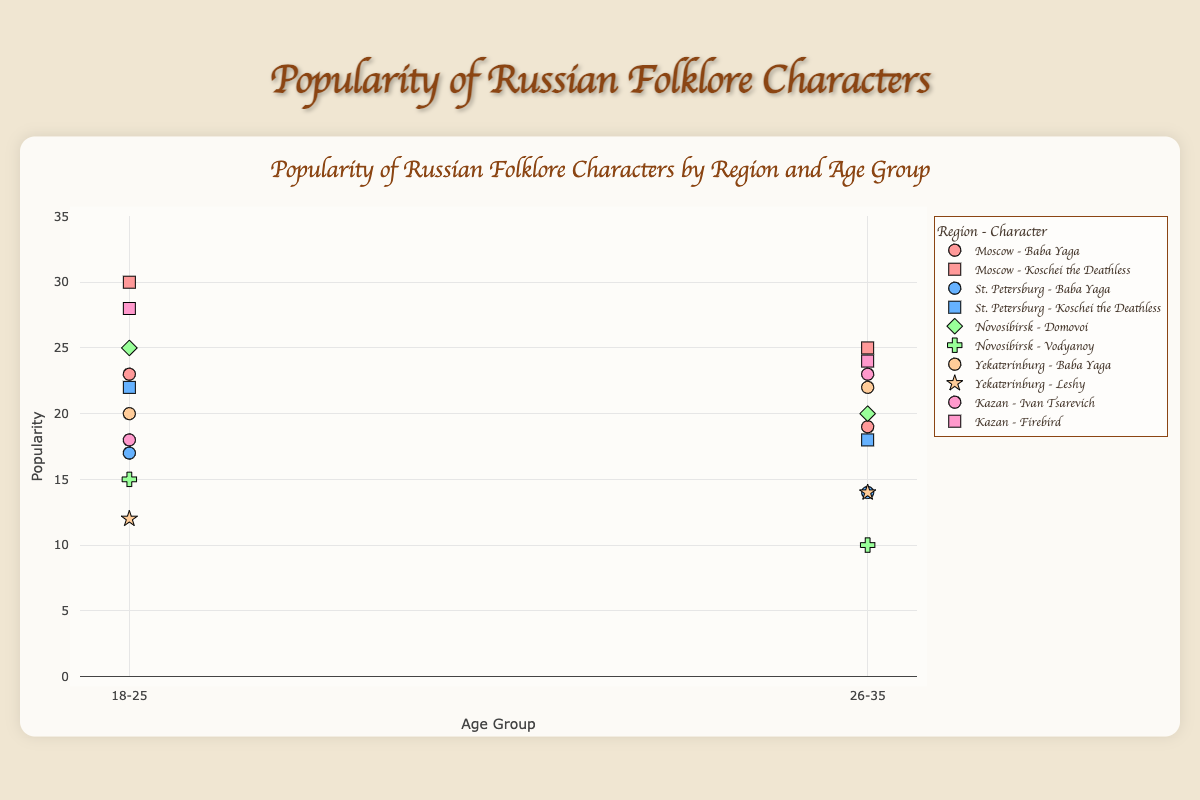Which age group in Moscow is most popular for Koschei the Deathless? The data shows the popularity of Koschei the Deathless in Moscow for two age groups: 18-25 with a popularity of 30, and 26-35 with a popularity of 25. Therefore, the 18-25 age group is more popular.
Answer: 18-25 How does the popularity of Baba Yaga compare between Moscow and St. Petersburg for the 18-25 age group? In Moscow, Baba Yaga has a popularity of 23 in the 18-25 age group, whereas in St. Petersburg, Baba Yaga's popularity is 17 for the same age group. Moscow has higher popularity for Baba Yaga in this age group.
Answer: Moscow What is the combined popularity of Domovoi in Novosibirsk for both age groups? The popularity of Domovoi in Novosibirsk for the 18-25 age group is 25, and for the 26-35 age group, it is 20. Adding these two numbers, 25 + 20, gives the combined popularity of 45.
Answer: 45 Which character has the lowest popularity in Yekaterinburg for the 18-25 age group? In Yekaterinburg, for the 18-25 age group, Leshy has a popularity of 12, and Baba Yaga has a popularity of 20. Thus, Leshy has the lowest popularity.
Answer: Leshy Compare the popularity of Firebird in Kazan between the two age groups. In Kazan, Firebird has a popularity of 28 in the 18-25 age group and 24 in the 26-35 age group. Therefore, Firebird is more popular in the 18-25 age group than in the 26-35 age group.
Answer: 18-25 What is the average popularity of Baba Yaga across all regions for the 26-35 age group? The popularity of Baba Yaga in the 26-35 age group is given as: Moscow (19), St. Petersburg (14), and Yekaterinburg (22). The sum is 19 + 14 + 22 = 55, and there are 3 data points, so the average is 55 / 3 = 18.33.
Answer: 18.33 Where is Koschei the Deathless more popular for the 18-25 age group: Moscow or St. Petersburg? In Moscow, the popularity of Koschei the Deathless for the 18-25 age group is 30, whereas in St. Petersburg, it is 22. Therefore, Koschei the Deathless is more popular in Moscow for this age group.
Answer: Moscow How does the popularity of Leshy in Yekaterinburg change between the two age groups? In Yekaterinburg, Leshy's popularity is 12 for the 18-25 age group and 14 for the 26-35 age group. Thus, Leshy's popularity increases from 12 to 14 as the age group shifts.
Answer: Increases 